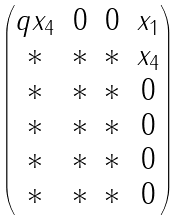<formula> <loc_0><loc_0><loc_500><loc_500>\begin{pmatrix} q x _ { 4 } & 0 & 0 & x _ { 1 } \\ * & * & * & x _ { 4 } \\ * & * & * & 0 \\ * & * & * & 0 \\ * & * & * & 0 \\ * & * & * & 0 \end{pmatrix}</formula> 